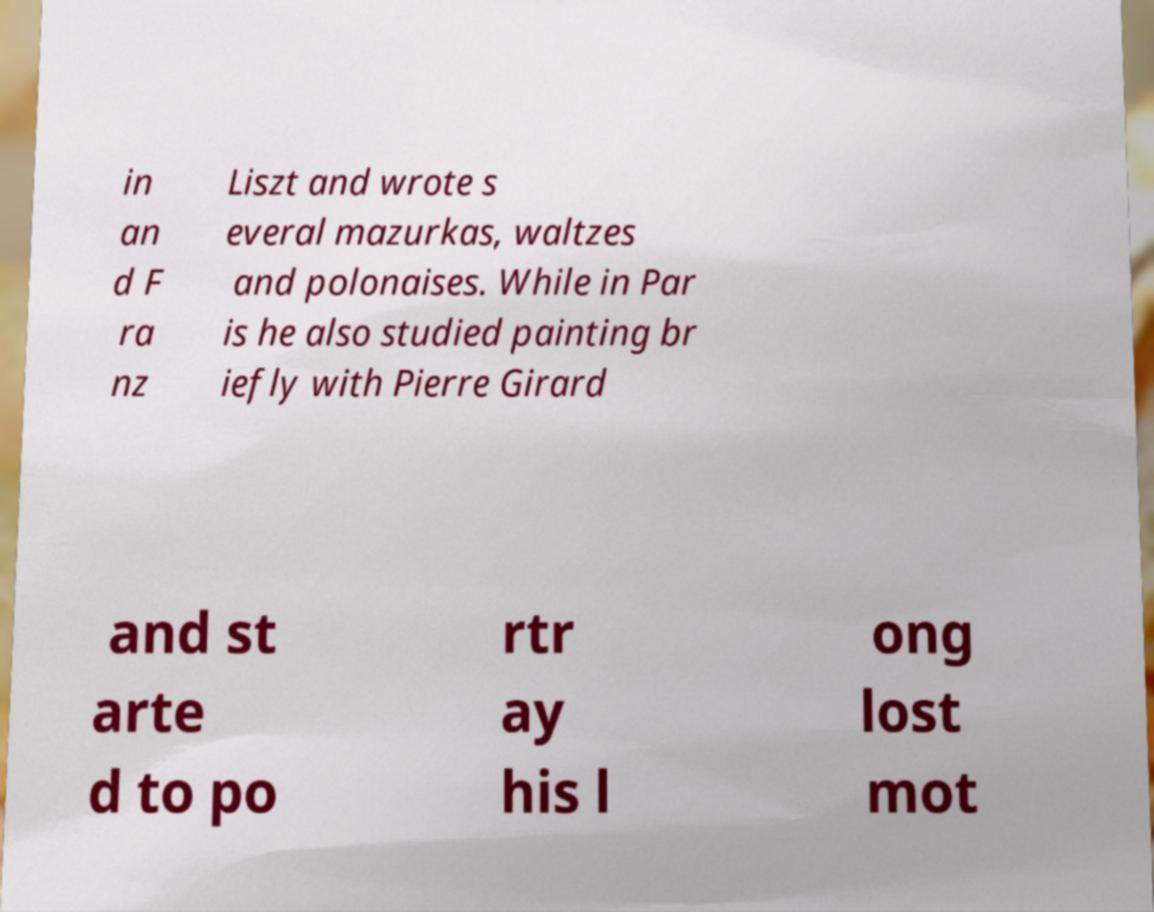Please identify and transcribe the text found in this image. in an d F ra nz Liszt and wrote s everal mazurkas, waltzes and polonaises. While in Par is he also studied painting br iefly with Pierre Girard and st arte d to po rtr ay his l ong lost mot 